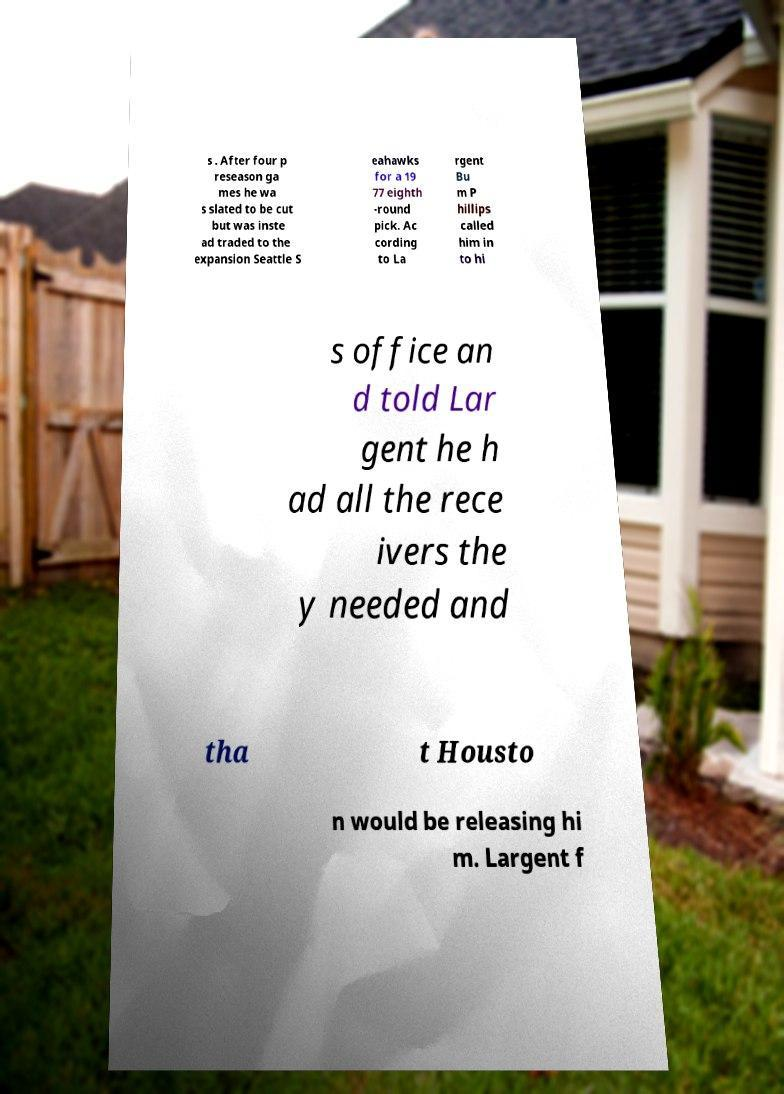Can you accurately transcribe the text from the provided image for me? s . After four p reseason ga mes he wa s slated to be cut but was inste ad traded to the expansion Seattle S eahawks for a 19 77 eighth -round pick. Ac cording to La rgent Bu m P hillips called him in to hi s office an d told Lar gent he h ad all the rece ivers the y needed and tha t Housto n would be releasing hi m. Largent f 